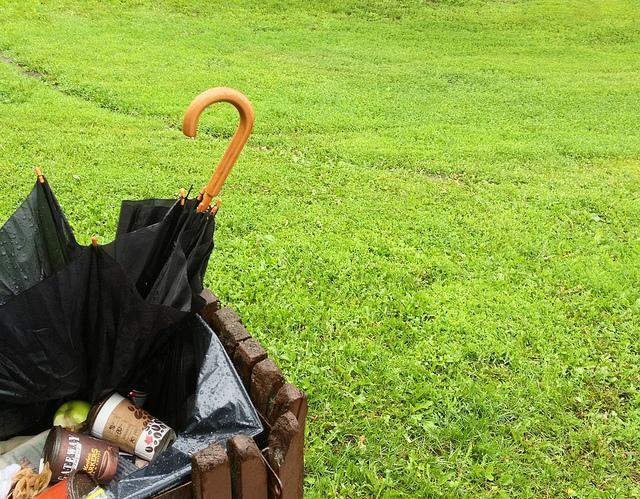How many cups of coffee are in the trash?
Give a very brief answer. 3. How many umbrellas are in the photo?
Give a very brief answer. 2. How many cups are there?
Give a very brief answer. 2. How many zebras are facing right in the picture?
Give a very brief answer. 0. 